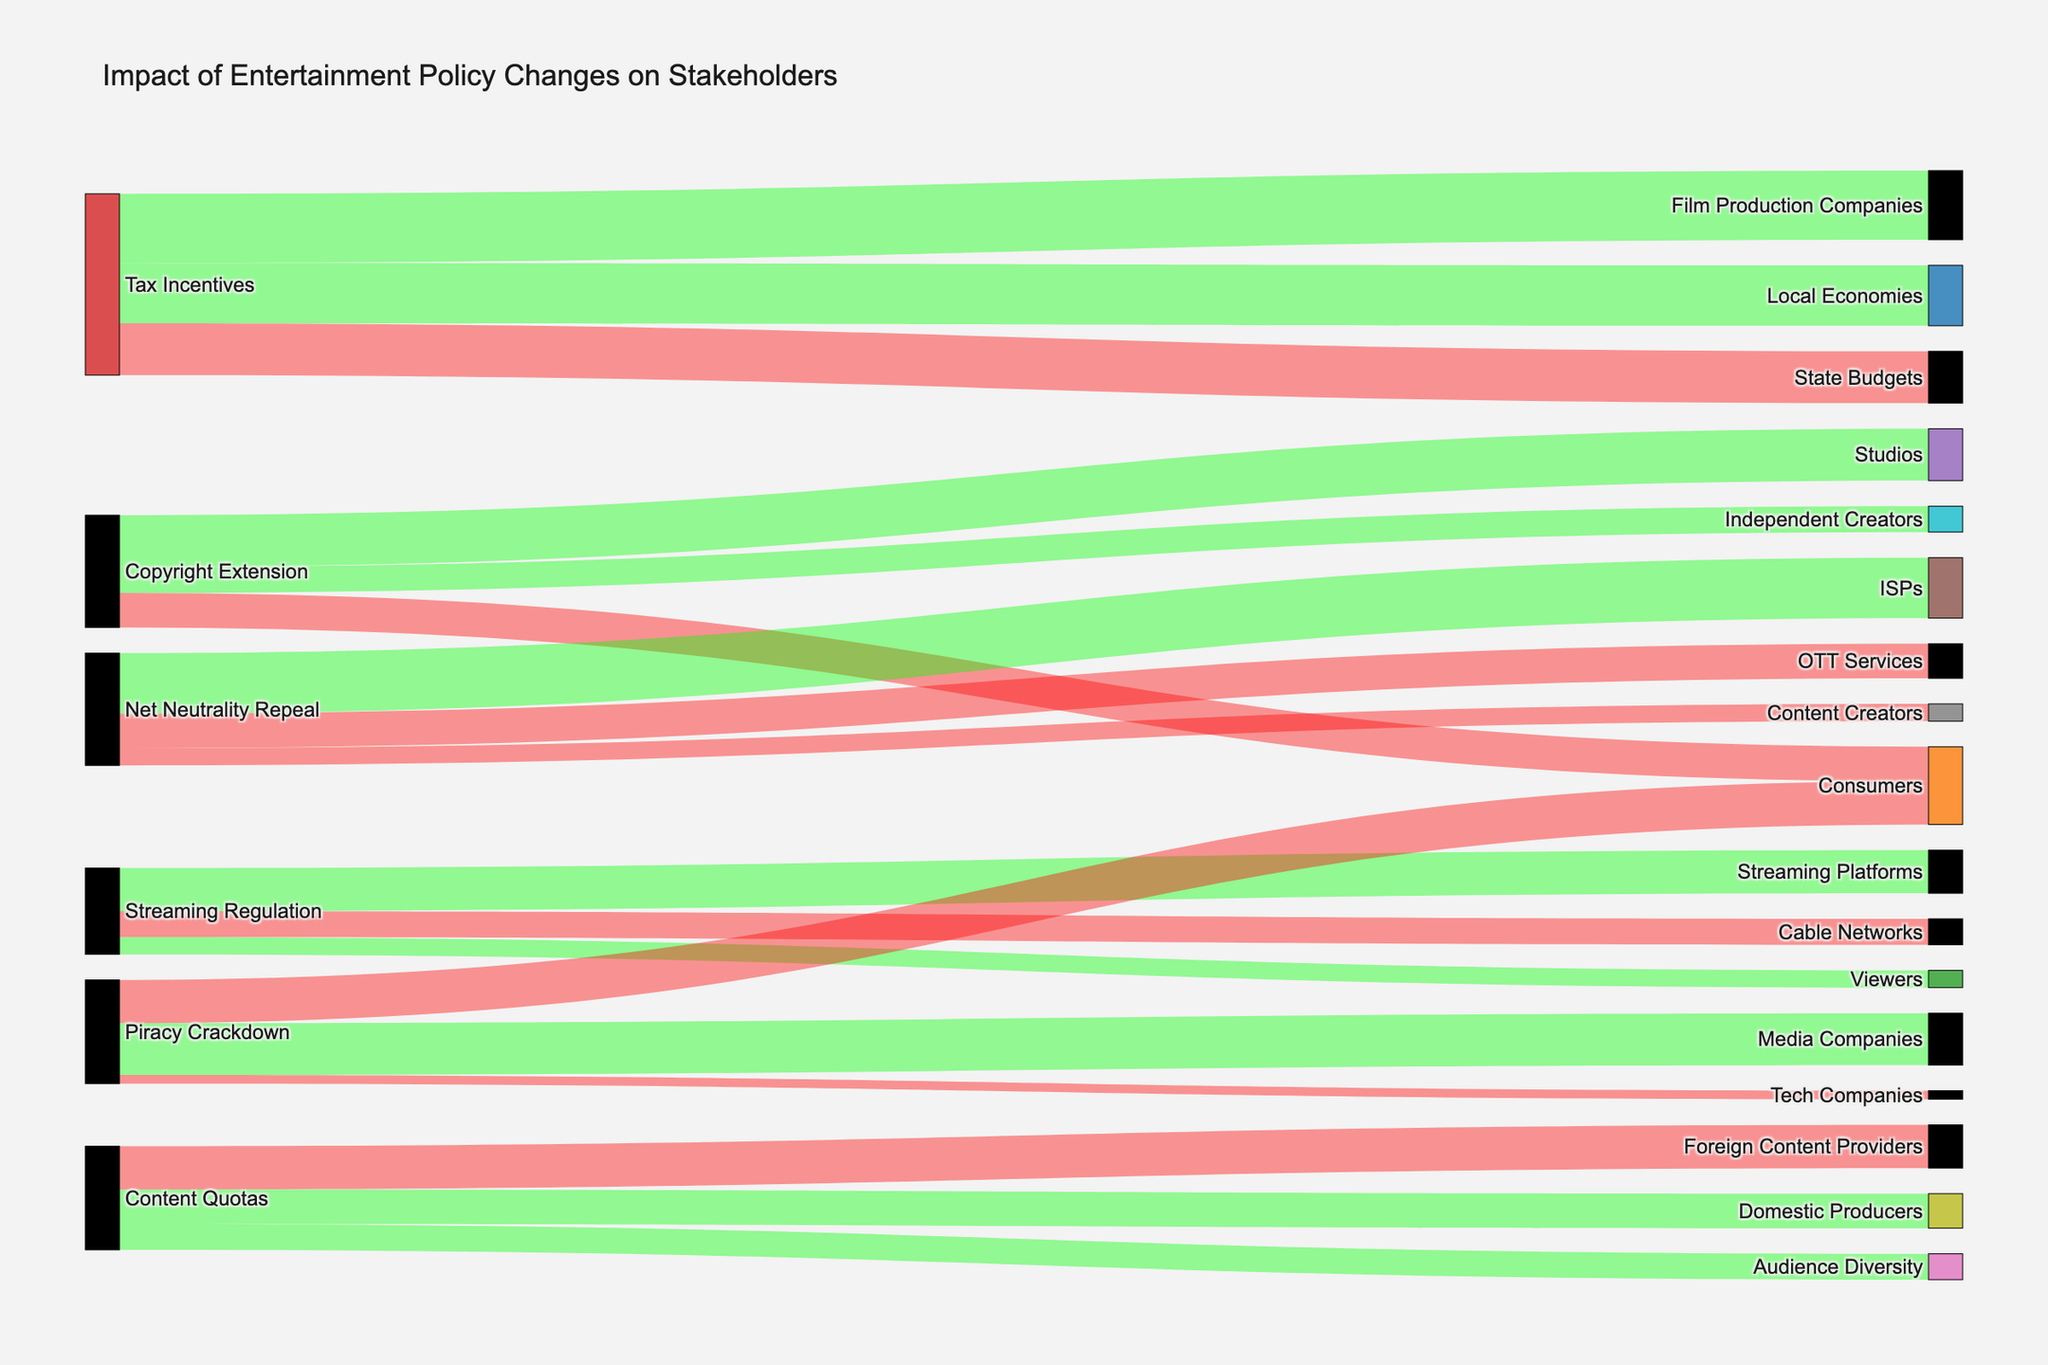What is the title of the figure? The title is located at the top of the figure, indicating the main subject of the Sankey Diagram, which summarizes the impact of various entertainment policy changes on different stakeholders.
Answer: Impact of Entertainment Policy Changes on Stakeholders Which stakeholder group benefits the most from Tax Incentives according to the figure? To determine which stakeholder benefits the most, we look for the group with the highest positive value connected to Tax Incentives. Film Production Companies have the highest positive value, 40.
Answer: Film Production Companies What is the total positive impact value of Copyright Extension? Sum the positive values for all stakeholders affected positively by Copyright Extension, which includes Studios (30) and Independent Creators (15). Summing these values, 30 + 15 = 45.
Answer: 45 What is the net impact of Streaming Regulation on all stakeholders? Calculate the net impact by summing the values for Streaming Platforms (25), Cable Networks (-15), and Viewers (10). 25 + (-15) + 10 = 20.
Answer: 20 Which policy change leads to a negative impact on both Consumers and Content Creators? From the diagram, identify the policy changes that have lines leading from them to both Consumers and Content Creators with negative values. The Net Neutrality Repeal impacts Content Creators (-10) and Piracy Crackdown impacts Consumers (-25), so it's not applicable for both. Streaming Regulation impacts Viewers positively. Therefore, no single policy  change meets the condition.
Answer: None How does the impact on Local Economies compare to the impact on State Budgets from Tax Incentives? Compare the positive impact on Local Economies (35) with the negative impact on State Budgets (-30). 35 is larger in absolute value than -30 indicating a greater impact on Local Economies.
Answer: Local Economies are more positively impacted than State Budgets are negatively impacted Which content quota policy results in the largest negative impact, and on which stakeholder group? Identify the policy changes under Content Quotas and find the one with the largest negative value. The negative impact for Foreign Content Providers is -25, which is the largest under Content Quotas.
Answer: Content Quotas on Foreign Content Providers What is the overall impact on consumers across all policies? Sum the impacts on Consumers from different policies: Copyright Extension (-20), Piracy Crackdown (-25). Adding these, -20 + (-25) = -45.
Answer: -45 Which policy change results in the highest negative impact value, and what is that value? Look for the policy with the highest absolute negative value in the diagram. Piracy Crackdown has a value of -25 which is the highest negative impact.
Answer: Piracy Crackdown with -25 